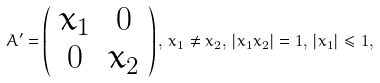Convert formula to latex. <formula><loc_0><loc_0><loc_500><loc_500>A ^ { \prime } = \left ( \begin{array} { c c } x _ { 1 } & 0 \\ 0 & x _ { 2 } \end{array} \right ) , \, x _ { 1 } \neq x _ { 2 } , \, | x _ { 1 } x _ { 2 } | = 1 , \, | x _ { 1 } | \leq 1 ,</formula> 